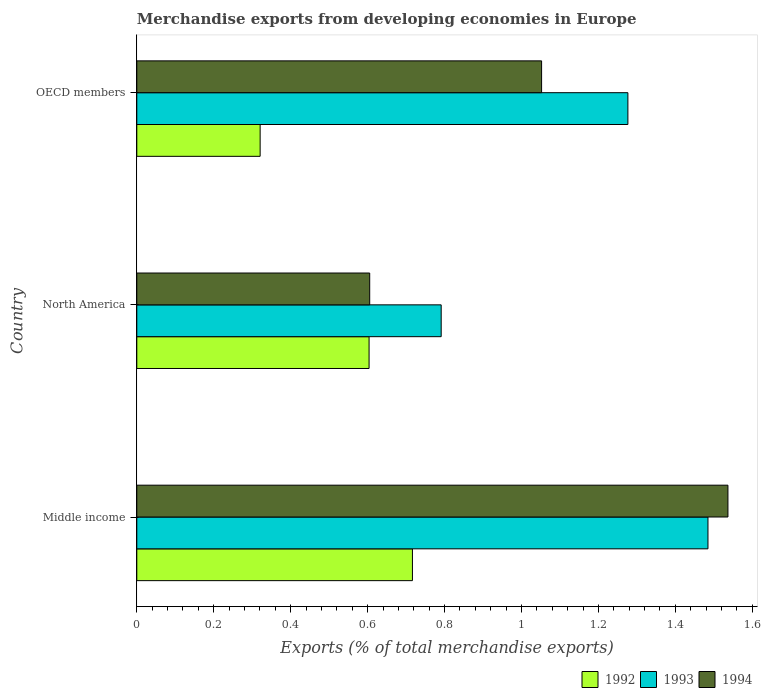How many different coloured bars are there?
Offer a terse response. 3. How many groups of bars are there?
Provide a succinct answer. 3. How many bars are there on the 2nd tick from the bottom?
Give a very brief answer. 3. What is the label of the 1st group of bars from the top?
Offer a very short reply. OECD members. In how many cases, is the number of bars for a given country not equal to the number of legend labels?
Provide a short and direct response. 0. What is the percentage of total merchandise exports in 1993 in OECD members?
Offer a very short reply. 1.28. Across all countries, what is the maximum percentage of total merchandise exports in 1994?
Keep it short and to the point. 1.54. Across all countries, what is the minimum percentage of total merchandise exports in 1992?
Give a very brief answer. 0.32. In which country was the percentage of total merchandise exports in 1994 maximum?
Your response must be concise. Middle income. What is the total percentage of total merchandise exports in 1994 in the graph?
Offer a very short reply. 3.19. What is the difference between the percentage of total merchandise exports in 1994 in Middle income and that in OECD members?
Provide a succinct answer. 0.48. What is the difference between the percentage of total merchandise exports in 1992 in Middle income and the percentage of total merchandise exports in 1993 in North America?
Offer a terse response. -0.07. What is the average percentage of total merchandise exports in 1992 per country?
Your answer should be very brief. 0.55. What is the difference between the percentage of total merchandise exports in 1992 and percentage of total merchandise exports in 1993 in Middle income?
Offer a very short reply. -0.77. What is the ratio of the percentage of total merchandise exports in 1993 in Middle income to that in OECD members?
Provide a short and direct response. 1.16. Is the percentage of total merchandise exports in 1993 in North America less than that in OECD members?
Provide a succinct answer. Yes. What is the difference between the highest and the second highest percentage of total merchandise exports in 1992?
Provide a succinct answer. 0.11. What is the difference between the highest and the lowest percentage of total merchandise exports in 1992?
Keep it short and to the point. 0.4. In how many countries, is the percentage of total merchandise exports in 1993 greater than the average percentage of total merchandise exports in 1993 taken over all countries?
Ensure brevity in your answer.  2. What does the 1st bar from the top in Middle income represents?
Provide a short and direct response. 1994. What does the 2nd bar from the bottom in North America represents?
Provide a short and direct response. 1993. How many bars are there?
Make the answer very short. 9. How many countries are there in the graph?
Your answer should be compact. 3. Are the values on the major ticks of X-axis written in scientific E-notation?
Offer a very short reply. No. Does the graph contain grids?
Your answer should be very brief. No. Where does the legend appear in the graph?
Give a very brief answer. Bottom right. What is the title of the graph?
Offer a terse response. Merchandise exports from developing economies in Europe. What is the label or title of the X-axis?
Your response must be concise. Exports (% of total merchandise exports). What is the Exports (% of total merchandise exports) of 1992 in Middle income?
Your response must be concise. 0.72. What is the Exports (% of total merchandise exports) of 1993 in Middle income?
Offer a very short reply. 1.48. What is the Exports (% of total merchandise exports) of 1994 in Middle income?
Your answer should be very brief. 1.54. What is the Exports (% of total merchandise exports) in 1992 in North America?
Give a very brief answer. 0.6. What is the Exports (% of total merchandise exports) of 1993 in North America?
Your response must be concise. 0.79. What is the Exports (% of total merchandise exports) in 1994 in North America?
Ensure brevity in your answer.  0.61. What is the Exports (% of total merchandise exports) in 1992 in OECD members?
Provide a succinct answer. 0.32. What is the Exports (% of total merchandise exports) in 1993 in OECD members?
Give a very brief answer. 1.28. What is the Exports (% of total merchandise exports) in 1994 in OECD members?
Provide a short and direct response. 1.05. Across all countries, what is the maximum Exports (% of total merchandise exports) in 1992?
Keep it short and to the point. 0.72. Across all countries, what is the maximum Exports (% of total merchandise exports) of 1993?
Your answer should be very brief. 1.48. Across all countries, what is the maximum Exports (% of total merchandise exports) of 1994?
Offer a very short reply. 1.54. Across all countries, what is the minimum Exports (% of total merchandise exports) of 1992?
Offer a very short reply. 0.32. Across all countries, what is the minimum Exports (% of total merchandise exports) in 1993?
Offer a terse response. 0.79. Across all countries, what is the minimum Exports (% of total merchandise exports) of 1994?
Offer a terse response. 0.61. What is the total Exports (% of total merchandise exports) in 1992 in the graph?
Offer a terse response. 1.64. What is the total Exports (% of total merchandise exports) in 1993 in the graph?
Provide a succinct answer. 3.55. What is the total Exports (% of total merchandise exports) of 1994 in the graph?
Your answer should be very brief. 3.19. What is the difference between the Exports (% of total merchandise exports) of 1992 in Middle income and that in North America?
Make the answer very short. 0.11. What is the difference between the Exports (% of total merchandise exports) of 1993 in Middle income and that in North America?
Your answer should be very brief. 0.69. What is the difference between the Exports (% of total merchandise exports) in 1994 in Middle income and that in North America?
Keep it short and to the point. 0.93. What is the difference between the Exports (% of total merchandise exports) of 1992 in Middle income and that in OECD members?
Provide a short and direct response. 0.4. What is the difference between the Exports (% of total merchandise exports) in 1993 in Middle income and that in OECD members?
Offer a very short reply. 0.21. What is the difference between the Exports (% of total merchandise exports) of 1994 in Middle income and that in OECD members?
Make the answer very short. 0.48. What is the difference between the Exports (% of total merchandise exports) of 1992 in North America and that in OECD members?
Ensure brevity in your answer.  0.28. What is the difference between the Exports (% of total merchandise exports) of 1993 in North America and that in OECD members?
Your response must be concise. -0.49. What is the difference between the Exports (% of total merchandise exports) in 1994 in North America and that in OECD members?
Provide a short and direct response. -0.45. What is the difference between the Exports (% of total merchandise exports) in 1992 in Middle income and the Exports (% of total merchandise exports) in 1993 in North America?
Provide a short and direct response. -0.07. What is the difference between the Exports (% of total merchandise exports) of 1992 in Middle income and the Exports (% of total merchandise exports) of 1994 in North America?
Provide a succinct answer. 0.11. What is the difference between the Exports (% of total merchandise exports) of 1993 in Middle income and the Exports (% of total merchandise exports) of 1994 in North America?
Your answer should be compact. 0.88. What is the difference between the Exports (% of total merchandise exports) of 1992 in Middle income and the Exports (% of total merchandise exports) of 1993 in OECD members?
Give a very brief answer. -0.56. What is the difference between the Exports (% of total merchandise exports) of 1992 in Middle income and the Exports (% of total merchandise exports) of 1994 in OECD members?
Keep it short and to the point. -0.34. What is the difference between the Exports (% of total merchandise exports) of 1993 in Middle income and the Exports (% of total merchandise exports) of 1994 in OECD members?
Your answer should be compact. 0.43. What is the difference between the Exports (% of total merchandise exports) of 1992 in North America and the Exports (% of total merchandise exports) of 1993 in OECD members?
Make the answer very short. -0.67. What is the difference between the Exports (% of total merchandise exports) in 1992 in North America and the Exports (% of total merchandise exports) in 1994 in OECD members?
Offer a terse response. -0.45. What is the difference between the Exports (% of total merchandise exports) of 1993 in North America and the Exports (% of total merchandise exports) of 1994 in OECD members?
Give a very brief answer. -0.26. What is the average Exports (% of total merchandise exports) of 1992 per country?
Offer a very short reply. 0.55. What is the average Exports (% of total merchandise exports) of 1993 per country?
Your response must be concise. 1.18. What is the average Exports (% of total merchandise exports) of 1994 per country?
Give a very brief answer. 1.06. What is the difference between the Exports (% of total merchandise exports) in 1992 and Exports (% of total merchandise exports) in 1993 in Middle income?
Your answer should be compact. -0.77. What is the difference between the Exports (% of total merchandise exports) in 1992 and Exports (% of total merchandise exports) in 1994 in Middle income?
Provide a short and direct response. -0.82. What is the difference between the Exports (% of total merchandise exports) in 1993 and Exports (% of total merchandise exports) in 1994 in Middle income?
Your response must be concise. -0.05. What is the difference between the Exports (% of total merchandise exports) of 1992 and Exports (% of total merchandise exports) of 1993 in North America?
Provide a succinct answer. -0.19. What is the difference between the Exports (% of total merchandise exports) in 1992 and Exports (% of total merchandise exports) in 1994 in North America?
Provide a short and direct response. -0. What is the difference between the Exports (% of total merchandise exports) of 1993 and Exports (% of total merchandise exports) of 1994 in North America?
Your response must be concise. 0.19. What is the difference between the Exports (% of total merchandise exports) of 1992 and Exports (% of total merchandise exports) of 1993 in OECD members?
Your answer should be very brief. -0.96. What is the difference between the Exports (% of total merchandise exports) in 1992 and Exports (% of total merchandise exports) in 1994 in OECD members?
Offer a very short reply. -0.73. What is the difference between the Exports (% of total merchandise exports) in 1993 and Exports (% of total merchandise exports) in 1994 in OECD members?
Keep it short and to the point. 0.22. What is the ratio of the Exports (% of total merchandise exports) in 1992 in Middle income to that in North America?
Ensure brevity in your answer.  1.19. What is the ratio of the Exports (% of total merchandise exports) in 1993 in Middle income to that in North America?
Make the answer very short. 1.88. What is the ratio of the Exports (% of total merchandise exports) in 1994 in Middle income to that in North America?
Your response must be concise. 2.54. What is the ratio of the Exports (% of total merchandise exports) of 1992 in Middle income to that in OECD members?
Provide a succinct answer. 2.23. What is the ratio of the Exports (% of total merchandise exports) of 1993 in Middle income to that in OECD members?
Your answer should be compact. 1.16. What is the ratio of the Exports (% of total merchandise exports) of 1994 in Middle income to that in OECD members?
Your answer should be compact. 1.46. What is the ratio of the Exports (% of total merchandise exports) of 1992 in North America to that in OECD members?
Your response must be concise. 1.88. What is the ratio of the Exports (% of total merchandise exports) of 1993 in North America to that in OECD members?
Ensure brevity in your answer.  0.62. What is the ratio of the Exports (% of total merchandise exports) of 1994 in North America to that in OECD members?
Provide a short and direct response. 0.58. What is the difference between the highest and the second highest Exports (% of total merchandise exports) of 1992?
Provide a short and direct response. 0.11. What is the difference between the highest and the second highest Exports (% of total merchandise exports) of 1993?
Your answer should be very brief. 0.21. What is the difference between the highest and the second highest Exports (% of total merchandise exports) in 1994?
Keep it short and to the point. 0.48. What is the difference between the highest and the lowest Exports (% of total merchandise exports) in 1992?
Your answer should be compact. 0.4. What is the difference between the highest and the lowest Exports (% of total merchandise exports) in 1993?
Ensure brevity in your answer.  0.69. What is the difference between the highest and the lowest Exports (% of total merchandise exports) in 1994?
Ensure brevity in your answer.  0.93. 